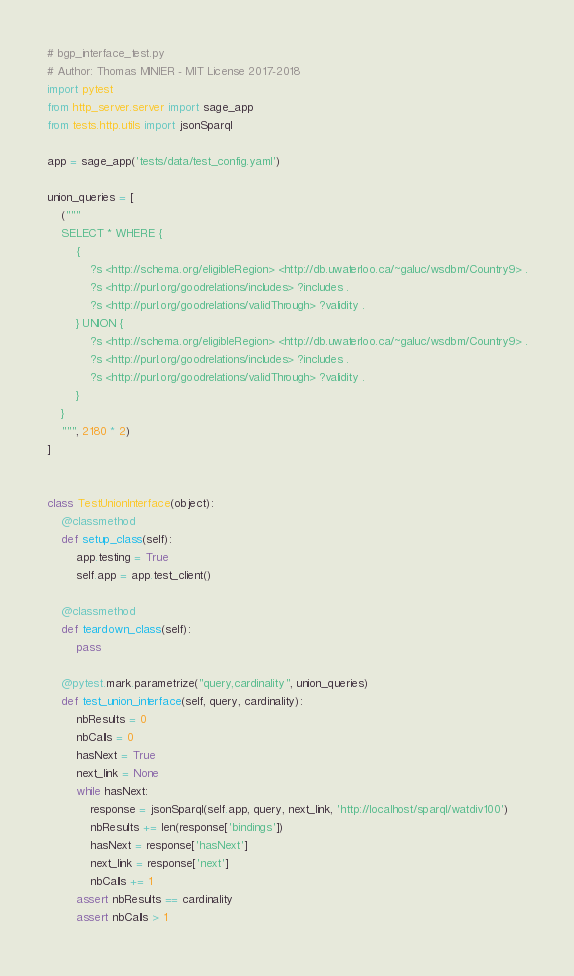Convert code to text. <code><loc_0><loc_0><loc_500><loc_500><_Python_># bgp_interface_test.py
# Author: Thomas MINIER - MIT License 2017-2018
import pytest
from http_server.server import sage_app
from tests.http.utils import jsonSparql

app = sage_app('tests/data/test_config.yaml')

union_queries = [
    ("""
    SELECT * WHERE {
        {
            ?s <http://schema.org/eligibleRegion> <http://db.uwaterloo.ca/~galuc/wsdbm/Country9> .
            ?s <http://purl.org/goodrelations/includes> ?includes .
            ?s <http://purl.org/goodrelations/validThrough> ?validity .
        } UNION {
            ?s <http://schema.org/eligibleRegion> <http://db.uwaterloo.ca/~galuc/wsdbm/Country9> .
            ?s <http://purl.org/goodrelations/includes> ?includes .
            ?s <http://purl.org/goodrelations/validThrough> ?validity .
        }
    }
    """, 2180 * 2)
]


class TestUnionInterface(object):
    @classmethod
    def setup_class(self):
        app.testing = True
        self.app = app.test_client()

    @classmethod
    def teardown_class(self):
        pass

    @pytest.mark.parametrize("query,cardinality", union_queries)
    def test_union_interface(self, query, cardinality):
        nbResults = 0
        nbCalls = 0
        hasNext = True
        next_link = None
        while hasNext:
            response = jsonSparql(self.app, query, next_link, 'http://localhost/sparql/watdiv100')
            nbResults += len(response['bindings'])
            hasNext = response['hasNext']
            next_link = response['next']
            nbCalls += 1
        assert nbResults == cardinality
        assert nbCalls > 1
</code> 